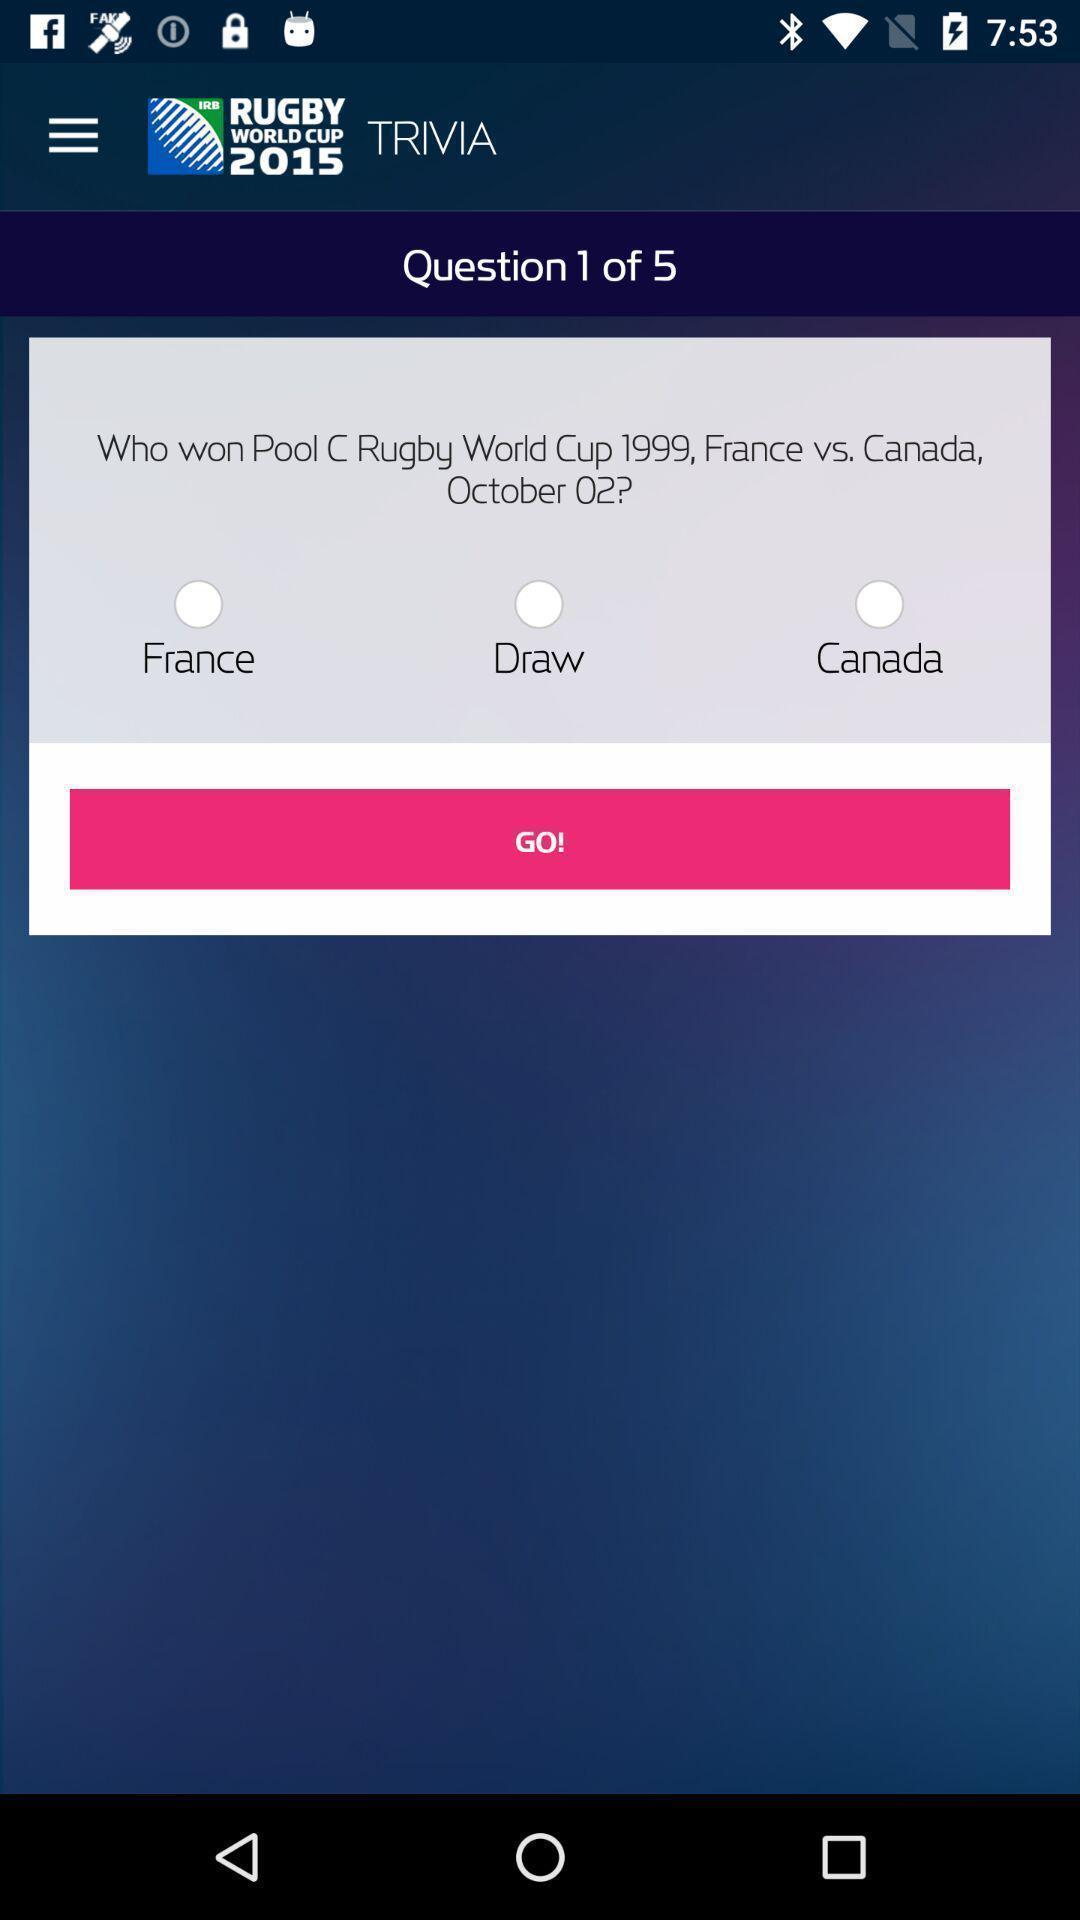Describe the key features of this screenshot. Screen showing question with multiple options. 